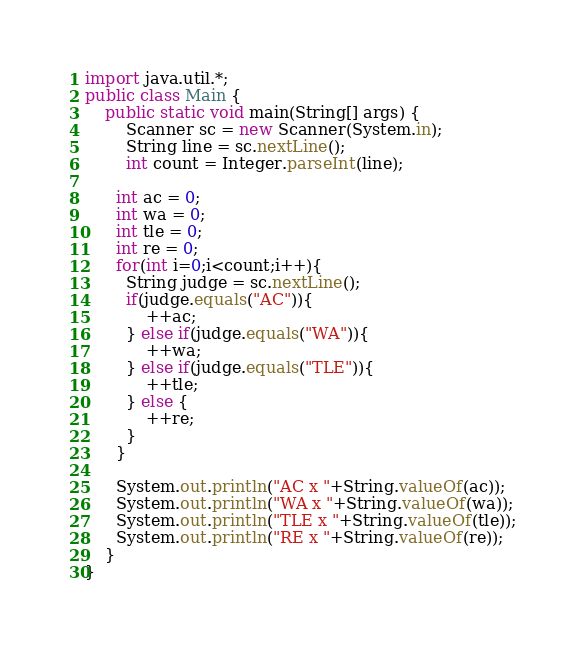Convert code to text. <code><loc_0><loc_0><loc_500><loc_500><_Java_>import java.util.*;
public class Main {
    public static void main(String[] args) {
        Scanner sc = new Scanner(System.in);
        String line = sc.nextLine();
        int count = Integer.parseInt(line);
      
      int ac = 0;
      int wa = 0;
      int tle = 0;
      int re = 0;
      for(int i=0;i<count;i++){
        String judge = sc.nextLine();
        if(judge.equals("AC")){
            ++ac;
        } else if(judge.equals("WA")){
            ++wa;
        } else if(judge.equals("TLE")){
            ++tle;
        } else {
            ++re;
        }
      }
      
      System.out.println("AC x "+String.valueOf(ac));
      System.out.println("WA x "+String.valueOf(wa));
      System.out.println("TLE x "+String.valueOf(tle));
      System.out.println("RE x "+String.valueOf(re));
    }
}</code> 